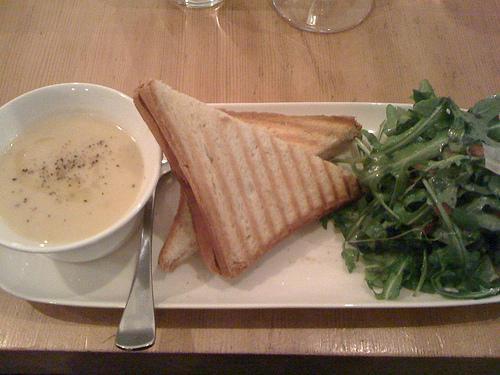How many sandwich slices are there?
Give a very brief answer. 2. How many spoons are there?
Give a very brief answer. 1. 